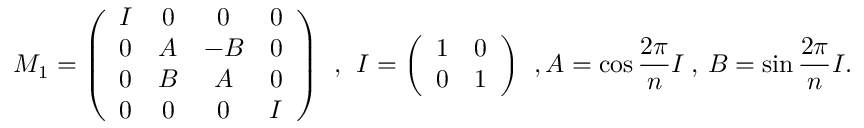Convert formula to latex. <formula><loc_0><loc_0><loc_500><loc_500>M _ { 1 } = \left ( \begin{array} { c c c c } { I } & { 0 } & { 0 } & { 0 } \\ { 0 } & { A } & { - B } & { 0 } \\ { 0 } & { B } & { A } & { 0 } \\ { 0 } & { 0 } & { 0 } & { I } \end{array} \right ) \, , \, I = \left ( \begin{array} { c c } { 1 } & { 0 } \\ { 0 } & { 1 } \end{array} \right ) \, , A = \cos \frac { 2 \pi } { n } I \, , \, B = \sin \frac { 2 \pi } { n } I .</formula> 